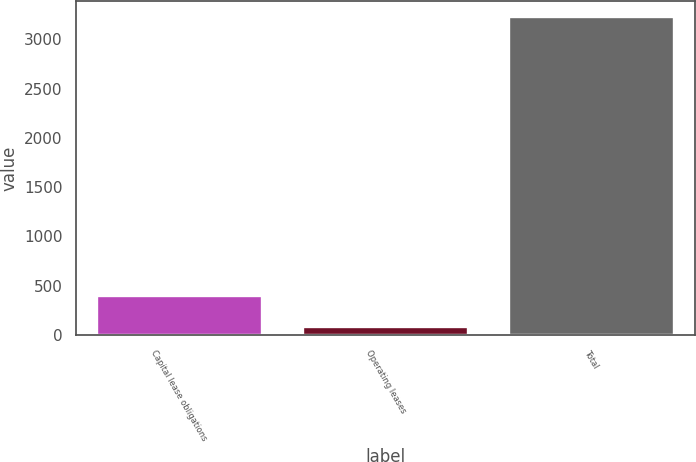Convert chart to OTSL. <chart><loc_0><loc_0><loc_500><loc_500><bar_chart><fcel>Capital lease obligations<fcel>Operating leases<fcel>Total<nl><fcel>395.2<fcel>81<fcel>3223<nl></chart> 